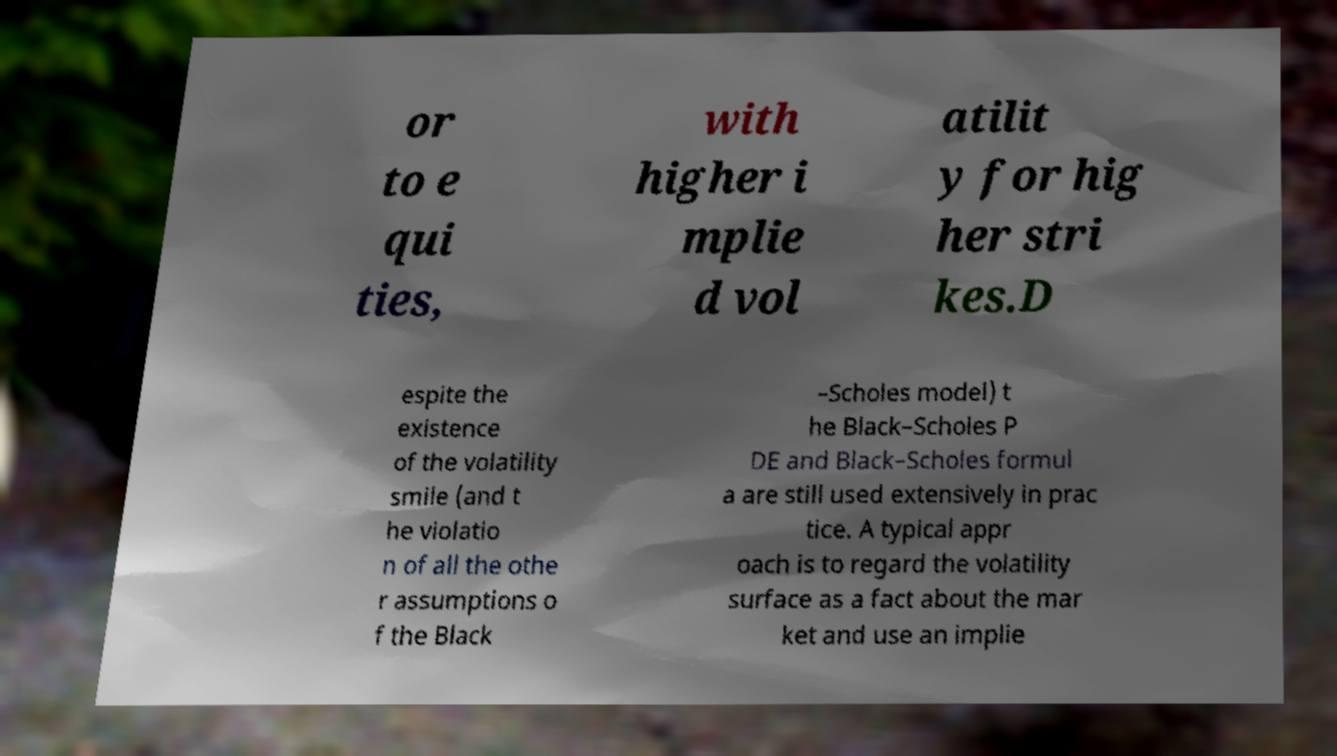Can you read and provide the text displayed in the image?This photo seems to have some interesting text. Can you extract and type it out for me? or to e qui ties, with higher i mplie d vol atilit y for hig her stri kes.D espite the existence of the volatility smile (and t he violatio n of all the othe r assumptions o f the Black –Scholes model) t he Black–Scholes P DE and Black–Scholes formul a are still used extensively in prac tice. A typical appr oach is to regard the volatility surface as a fact about the mar ket and use an implie 